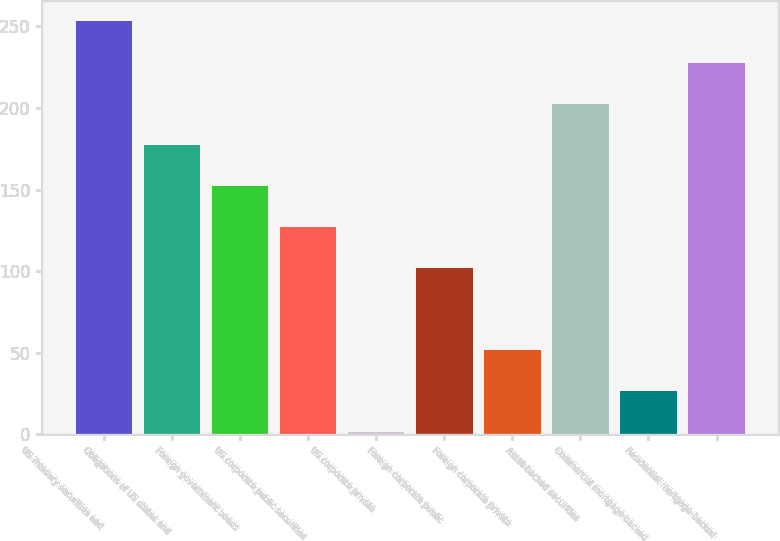Convert chart. <chart><loc_0><loc_0><loc_500><loc_500><bar_chart><fcel>US Treasury securities and<fcel>Obligations of US states and<fcel>Foreign government bonds<fcel>US corporate public securities<fcel>US corporate private<fcel>Foreign corporate public<fcel>Foreign corporate private<fcel>Asset-backed securities<fcel>Commercial mortgage-backed<fcel>Residential mortgage-backed<nl><fcel>253<fcel>177.46<fcel>152.29<fcel>127.12<fcel>1.27<fcel>101.95<fcel>51.61<fcel>202.63<fcel>26.44<fcel>227.8<nl></chart> 